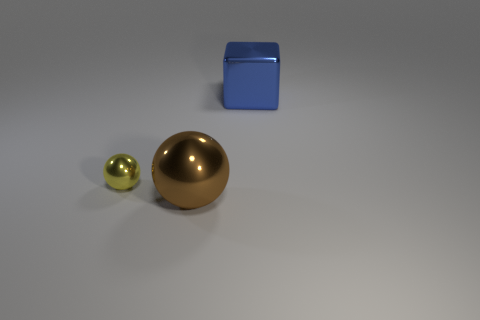Add 3 large brown metallic objects. How many objects exist? 6 Subtract all spheres. How many objects are left? 1 Subtract all small things. Subtract all shiny balls. How many objects are left? 0 Add 3 big brown metallic things. How many big brown metallic things are left? 4 Add 3 large purple matte cylinders. How many large purple matte cylinders exist? 3 Subtract 0 brown cylinders. How many objects are left? 3 